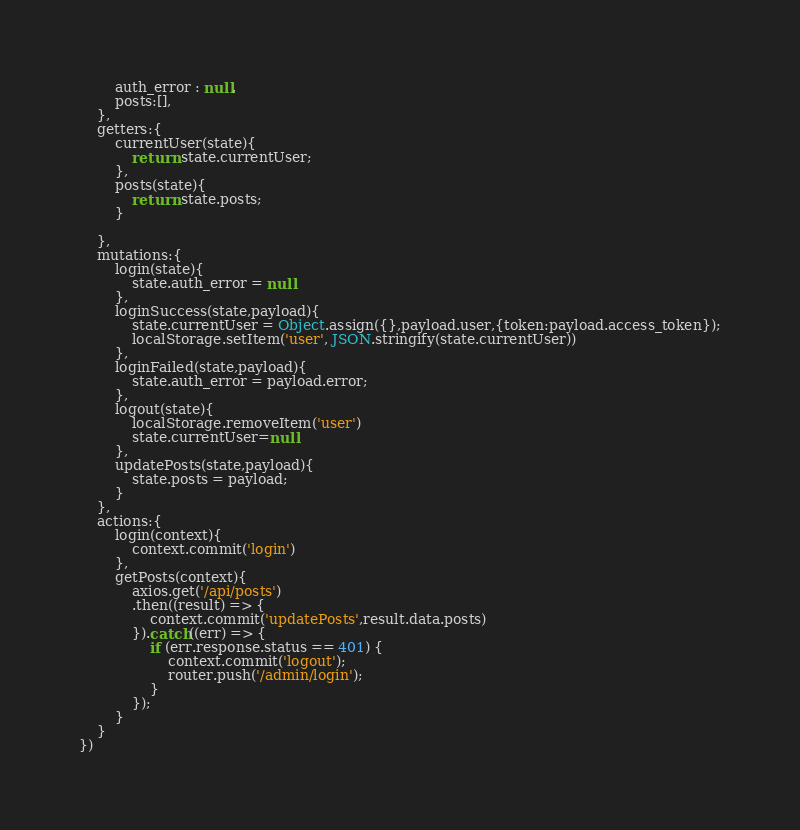<code> <loc_0><loc_0><loc_500><loc_500><_JavaScript_>        auth_error : null,
        posts:[],
    },
    getters:{
        currentUser(state){
            return state.currentUser;
        },
        posts(state){
            return state.posts;
        }

    },
    mutations:{
        login(state){
            state.auth_error = null
        },
        loginSuccess(state,payload){
            state.currentUser = Object.assign({},payload.user,{token:payload.access_token});
            localStorage.setItem('user', JSON.stringify(state.currentUser))
        },
        loginFailed(state,payload){
            state.auth_error = payload.error;
        },
        logout(state){
            localStorage.removeItem('user')
            state.currentUser=null
        },
        updatePosts(state,payload){
            state.posts = payload;
        }
    },
    actions:{
        login(context){
            context.commit('login')
        },
        getPosts(context){
            axios.get('/api/posts')
            .then((result) => {
                context.commit('updatePosts',result.data.posts)
            }).catch((err) => {
                if (err.response.status == 401) {
                    context.commit('logout');
                    router.push('/admin/login');
                }
            });
        }
    }
})</code> 